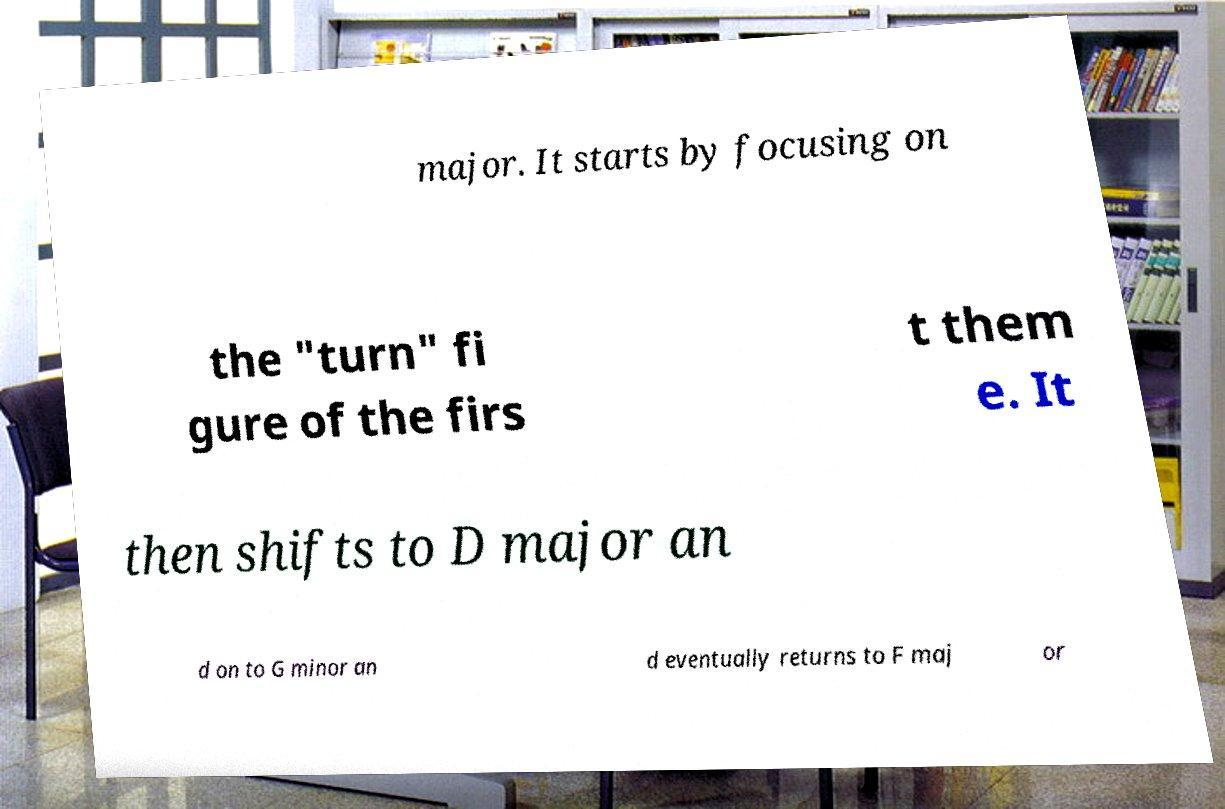For documentation purposes, I need the text within this image transcribed. Could you provide that? major. It starts by focusing on the "turn" fi gure of the firs t them e. It then shifts to D major an d on to G minor an d eventually returns to F maj or 